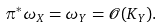Convert formula to latex. <formula><loc_0><loc_0><loc_500><loc_500>\pi ^ { * } \omega _ { X } = \omega _ { Y } = \mathcal { O } ( K _ { Y } ) .</formula> 